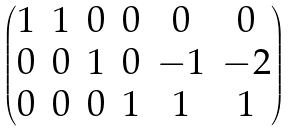Convert formula to latex. <formula><loc_0><loc_0><loc_500><loc_500>\begin{pmatrix} 1 & 1 & 0 & 0 & 0 & 0 \\ 0 & 0 & 1 & 0 & - 1 & - 2 \\ 0 & 0 & 0 & 1 & 1 & 1 \end{pmatrix}</formula> 